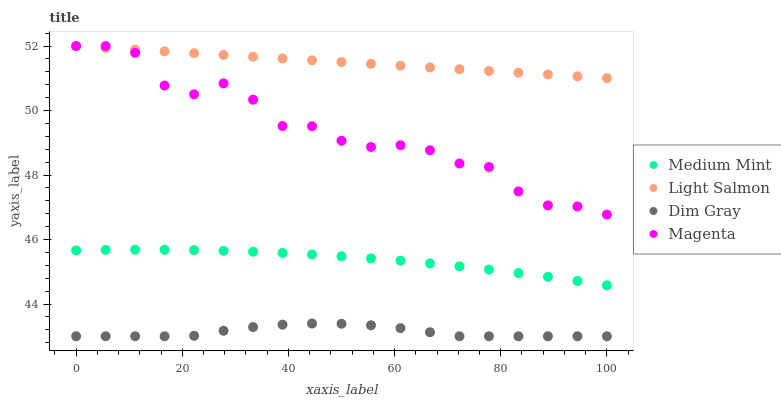Does Dim Gray have the minimum area under the curve?
Answer yes or no. Yes. Does Light Salmon have the maximum area under the curve?
Answer yes or no. Yes. Does Light Salmon have the minimum area under the curve?
Answer yes or no. No. Does Dim Gray have the maximum area under the curve?
Answer yes or no. No. Is Light Salmon the smoothest?
Answer yes or no. Yes. Is Magenta the roughest?
Answer yes or no. Yes. Is Dim Gray the smoothest?
Answer yes or no. No. Is Dim Gray the roughest?
Answer yes or no. No. Does Dim Gray have the lowest value?
Answer yes or no. Yes. Does Light Salmon have the lowest value?
Answer yes or no. No. Does Magenta have the highest value?
Answer yes or no. Yes. Does Dim Gray have the highest value?
Answer yes or no. No. Is Dim Gray less than Medium Mint?
Answer yes or no. Yes. Is Magenta greater than Medium Mint?
Answer yes or no. Yes. Does Magenta intersect Light Salmon?
Answer yes or no. Yes. Is Magenta less than Light Salmon?
Answer yes or no. No. Is Magenta greater than Light Salmon?
Answer yes or no. No. Does Dim Gray intersect Medium Mint?
Answer yes or no. No. 